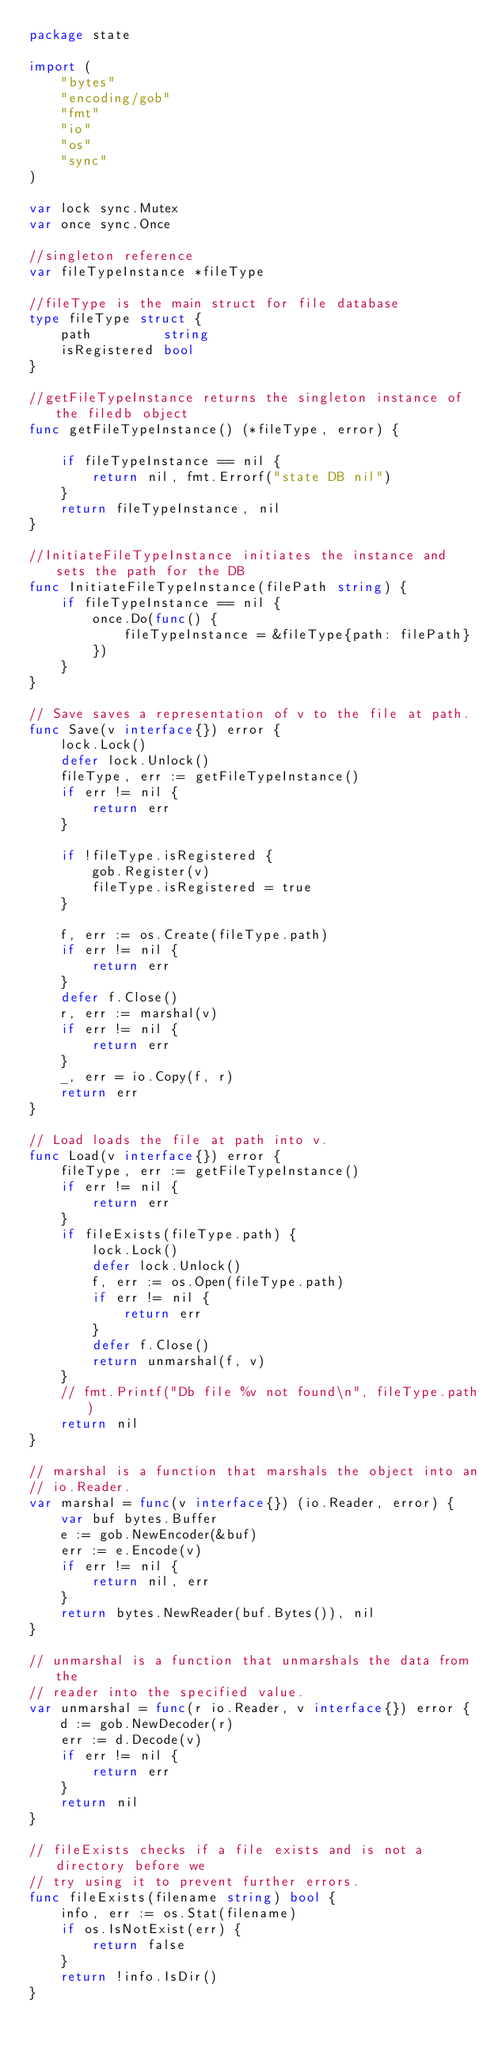Convert code to text. <code><loc_0><loc_0><loc_500><loc_500><_Go_>package state

import (
	"bytes"
	"encoding/gob"
	"fmt"
	"io"
	"os"
	"sync"
)

var lock sync.Mutex
var once sync.Once

//singleton reference
var fileTypeInstance *fileType

//fileType is the main struct for file database
type fileType struct {
	path         string
	isRegistered bool
}

//getFileTypeInstance returns the singleton instance of the filedb object
func getFileTypeInstance() (*fileType, error) {

	if fileTypeInstance == nil {
		return nil, fmt.Errorf("state DB nil")
	}
	return fileTypeInstance, nil
}

//InitiateFileTypeInstance initiates the instance and sets the path for the DB
func InitiateFileTypeInstance(filePath string) {
	if fileTypeInstance == nil {
		once.Do(func() {
			fileTypeInstance = &fileType{path: filePath}
		})
	}
}

// Save saves a representation of v to the file at path.
func Save(v interface{}) error {
	lock.Lock()
	defer lock.Unlock()
	fileType, err := getFileTypeInstance()
	if err != nil {
		return err
	}

	if !fileType.isRegistered {
		gob.Register(v)
		fileType.isRegistered = true
	}

	f, err := os.Create(fileType.path)
	if err != nil {
		return err
	}
	defer f.Close()
	r, err := marshal(v)
	if err != nil {
		return err
	}
	_, err = io.Copy(f, r)
	return err
}

// Load loads the file at path into v.
func Load(v interface{}) error {
	fileType, err := getFileTypeInstance()
	if err != nil {
		return err
	}
	if fileExists(fileType.path) {
		lock.Lock()
		defer lock.Unlock()
		f, err := os.Open(fileType.path)
		if err != nil {
			return err
		}
		defer f.Close()
		return unmarshal(f, v)
	}
	// fmt.Printf("Db file %v not found\n", fileType.path)
	return nil
}

// marshal is a function that marshals the object into an
// io.Reader.
var marshal = func(v interface{}) (io.Reader, error) {
	var buf bytes.Buffer
	e := gob.NewEncoder(&buf)
	err := e.Encode(v)
	if err != nil {
		return nil, err
	}
	return bytes.NewReader(buf.Bytes()), nil
}

// unmarshal is a function that unmarshals the data from the
// reader into the specified value.
var unmarshal = func(r io.Reader, v interface{}) error {
	d := gob.NewDecoder(r)
	err := d.Decode(v)
	if err != nil {
		return err
	}
	return nil
}

// fileExists checks if a file exists and is not a directory before we
// try using it to prevent further errors.
func fileExists(filename string) bool {
	info, err := os.Stat(filename)
	if os.IsNotExist(err) {
		return false
	}
	return !info.IsDir()
}
</code> 